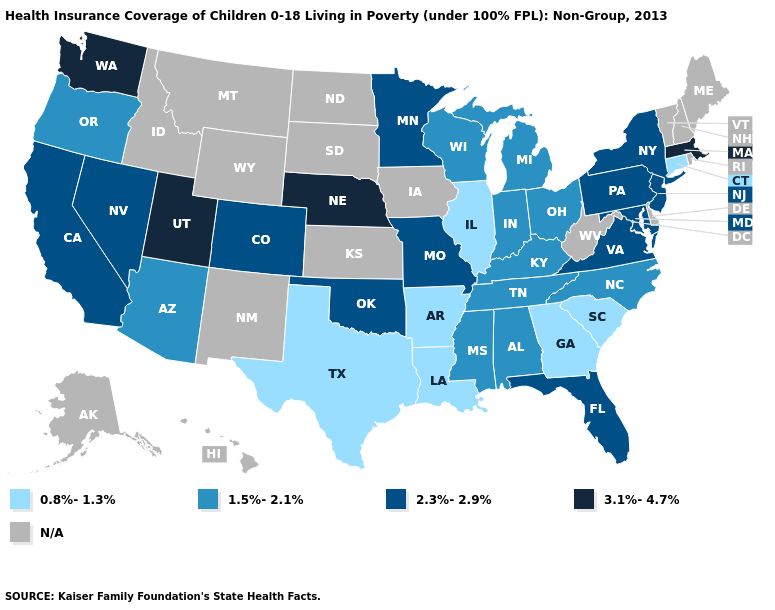What is the value of Pennsylvania?
Give a very brief answer. 2.3%-2.9%. What is the value of New Hampshire?
Be succinct. N/A. What is the lowest value in the USA?
Concise answer only. 0.8%-1.3%. What is the value of Florida?
Short answer required. 2.3%-2.9%. Name the states that have a value in the range 0.8%-1.3%?
Write a very short answer. Arkansas, Connecticut, Georgia, Illinois, Louisiana, South Carolina, Texas. Does the map have missing data?
Quick response, please. Yes. What is the highest value in the MidWest ?
Quick response, please. 3.1%-4.7%. Among the states that border New Mexico , does Utah have the highest value?
Be succinct. Yes. What is the value of California?
Concise answer only. 2.3%-2.9%. What is the highest value in the USA?
Keep it brief. 3.1%-4.7%. Which states have the lowest value in the USA?
Short answer required. Arkansas, Connecticut, Georgia, Illinois, Louisiana, South Carolina, Texas. What is the value of Texas?
Quick response, please. 0.8%-1.3%. What is the lowest value in states that border Kansas?
Write a very short answer. 2.3%-2.9%. Does Nebraska have the highest value in the MidWest?
Be succinct. Yes. 